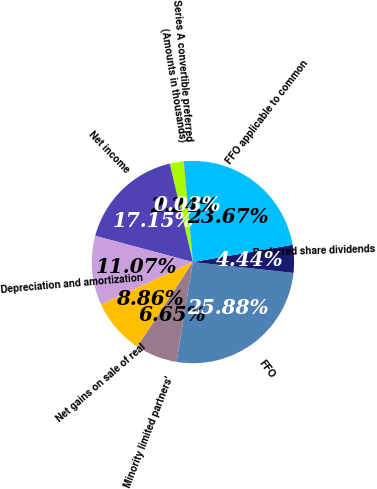Convert chart to OTSL. <chart><loc_0><loc_0><loc_500><loc_500><pie_chart><fcel>(Amounts in thousands)<fcel>Net income<fcel>Depreciation and amortization<fcel>Net gains on sale of real<fcel>Minority limited partners'<fcel>FFO<fcel>Preferred share dividends<fcel>FFO applicable to common<fcel>Series A convertible preferred<nl><fcel>2.24%<fcel>17.15%<fcel>11.07%<fcel>8.86%<fcel>6.65%<fcel>25.88%<fcel>4.44%<fcel>23.67%<fcel>0.03%<nl></chart> 